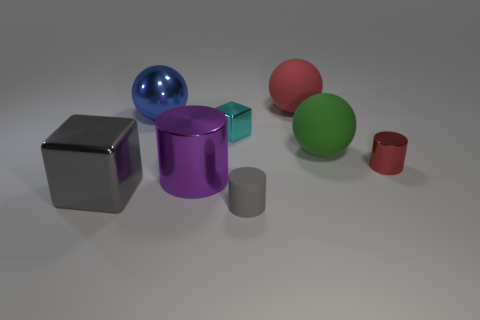Subtract all large red rubber spheres. How many spheres are left? 2 Add 1 large blue metallic spheres. How many objects exist? 9 Subtract 1 cylinders. How many cylinders are left? 2 Subtract 0 gray balls. How many objects are left? 8 Subtract all cylinders. How many objects are left? 5 Subtract all cyan cylinders. Subtract all blue cubes. How many cylinders are left? 3 Subtract all big yellow metallic balls. Subtract all metallic blocks. How many objects are left? 6 Add 4 small gray rubber cylinders. How many small gray rubber cylinders are left? 5 Add 7 blue shiny balls. How many blue shiny balls exist? 8 